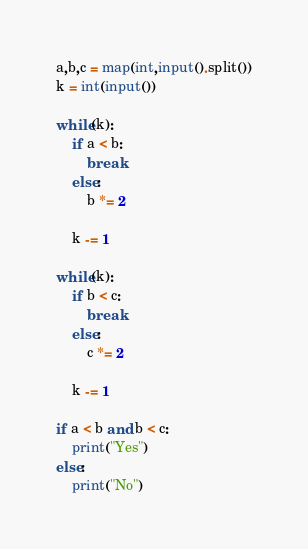<code> <loc_0><loc_0><loc_500><loc_500><_Python_>a,b,c = map(int,input().split())
k = int(input())

while(k):
    if a < b:
        break
    else:
        b *= 2

    k -= 1

while(k):
    if b < c:
        break
    else:
        c *= 2

    k -= 1

if a < b and b < c:
    print("Yes")
else:
    print("No")</code> 